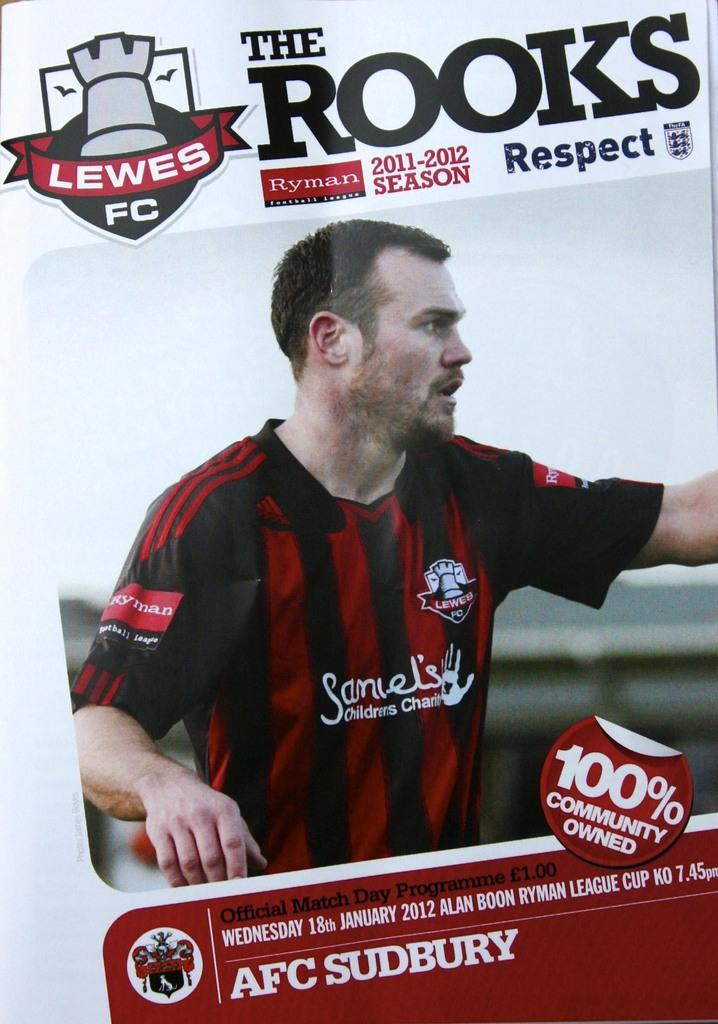Provide a one-sentence caption for the provided image. A soccer player on the cover of The Rooks magazine. 